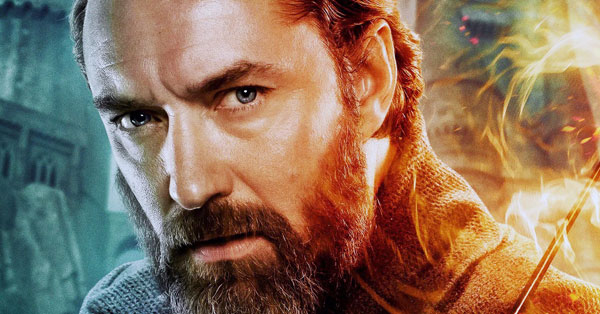Write a detailed description of the given image. In this high-resolution image, we see an actor captured in an intense close-up shot. His face is turned slightly to the side, as if he's gazing intently at something just out of frame. His expression is serious, deepening the dramatic tone of the image. He has well-groomed dark hair and a matching beard, which is meticulously styled. The background hints at a fantastical setting, with the blurred outline of a castle or grand structure visible. Adding to the mystical atmosphere, vivid orange sparks are flying around, illuminating the scene with a magical glow. This imagery strongly evokes themes from fantasy genres, potentially referencing a notable character from a well-known series. 